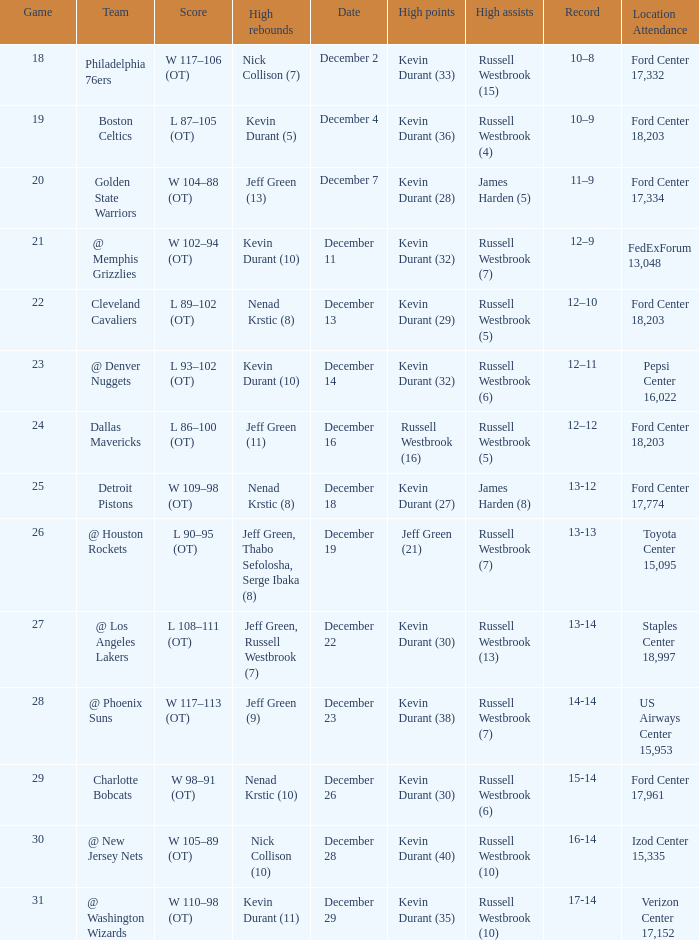Would you be able to parse every entry in this table? {'header': ['Game', 'Team', 'Score', 'High rebounds', 'Date', 'High points', 'High assists', 'Record', 'Location Attendance'], 'rows': [['18', 'Philadelphia 76ers', 'W 117–106 (OT)', 'Nick Collison (7)', 'December 2', 'Kevin Durant (33)', 'Russell Westbrook (15)', '10–8', 'Ford Center 17,332'], ['19', 'Boston Celtics', 'L 87–105 (OT)', 'Kevin Durant (5)', 'December 4', 'Kevin Durant (36)', 'Russell Westbrook (4)', '10–9', 'Ford Center 18,203'], ['20', 'Golden State Warriors', 'W 104–88 (OT)', 'Jeff Green (13)', 'December 7', 'Kevin Durant (28)', 'James Harden (5)', '11–9', 'Ford Center 17,334'], ['21', '@ Memphis Grizzlies', 'W 102–94 (OT)', 'Kevin Durant (10)', 'December 11', 'Kevin Durant (32)', 'Russell Westbrook (7)', '12–9', 'FedExForum 13,048'], ['22', 'Cleveland Cavaliers', 'L 89–102 (OT)', 'Nenad Krstic (8)', 'December 13', 'Kevin Durant (29)', 'Russell Westbrook (5)', '12–10', 'Ford Center 18,203'], ['23', '@ Denver Nuggets', 'L 93–102 (OT)', 'Kevin Durant (10)', 'December 14', 'Kevin Durant (32)', 'Russell Westbrook (6)', '12–11', 'Pepsi Center 16,022'], ['24', 'Dallas Mavericks', 'L 86–100 (OT)', 'Jeff Green (11)', 'December 16', 'Russell Westbrook (16)', 'Russell Westbrook (5)', '12–12', 'Ford Center 18,203'], ['25', 'Detroit Pistons', 'W 109–98 (OT)', 'Nenad Krstic (8)', 'December 18', 'Kevin Durant (27)', 'James Harden (8)', '13-12', 'Ford Center 17,774'], ['26', '@ Houston Rockets', 'L 90–95 (OT)', 'Jeff Green, Thabo Sefolosha, Serge Ibaka (8)', 'December 19', 'Jeff Green (21)', 'Russell Westbrook (7)', '13-13', 'Toyota Center 15,095'], ['27', '@ Los Angeles Lakers', 'L 108–111 (OT)', 'Jeff Green, Russell Westbrook (7)', 'December 22', 'Kevin Durant (30)', 'Russell Westbrook (13)', '13-14', 'Staples Center 18,997'], ['28', '@ Phoenix Suns', 'W 117–113 (OT)', 'Jeff Green (9)', 'December 23', 'Kevin Durant (38)', 'Russell Westbrook (7)', '14-14', 'US Airways Center 15,953'], ['29', 'Charlotte Bobcats', 'W 98–91 (OT)', 'Nenad Krstic (10)', 'December 26', 'Kevin Durant (30)', 'Russell Westbrook (6)', '15-14', 'Ford Center 17,961'], ['30', '@ New Jersey Nets', 'W 105–89 (OT)', 'Nick Collison (10)', 'December 28', 'Kevin Durant (40)', 'Russell Westbrook (10)', '16-14', 'Izod Center 15,335'], ['31', '@ Washington Wizards', 'W 110–98 (OT)', 'Kevin Durant (11)', 'December 29', 'Kevin Durant (35)', 'Russell Westbrook (10)', '17-14', 'Verizon Center 17,152']]} Who has high points when toyota center 15,095 is location attendance? Jeff Green (21). 